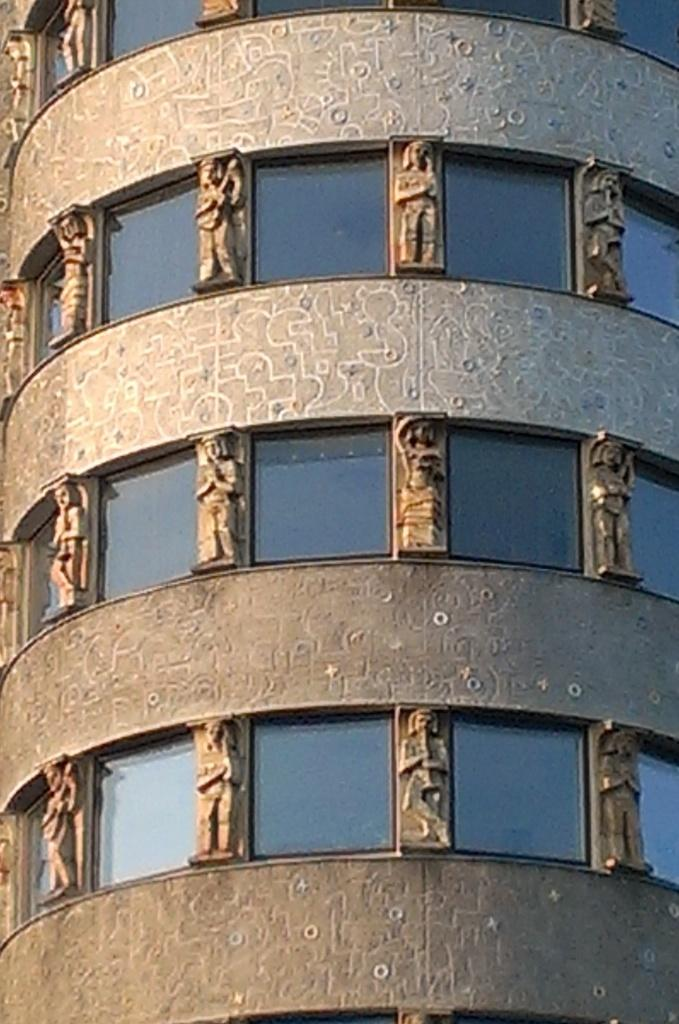What type of structure is visible in the image? There is a building in the image. What feature can be seen on the building? The building has windows. Are there any additional elements associated with the building? Yes, there are sculptures associated with the building. What type of nail is being used to hold the sculptures in place in the image? There is no nail visible in the image, and it is not mentioned that the sculptures are being held in place by any nails. 